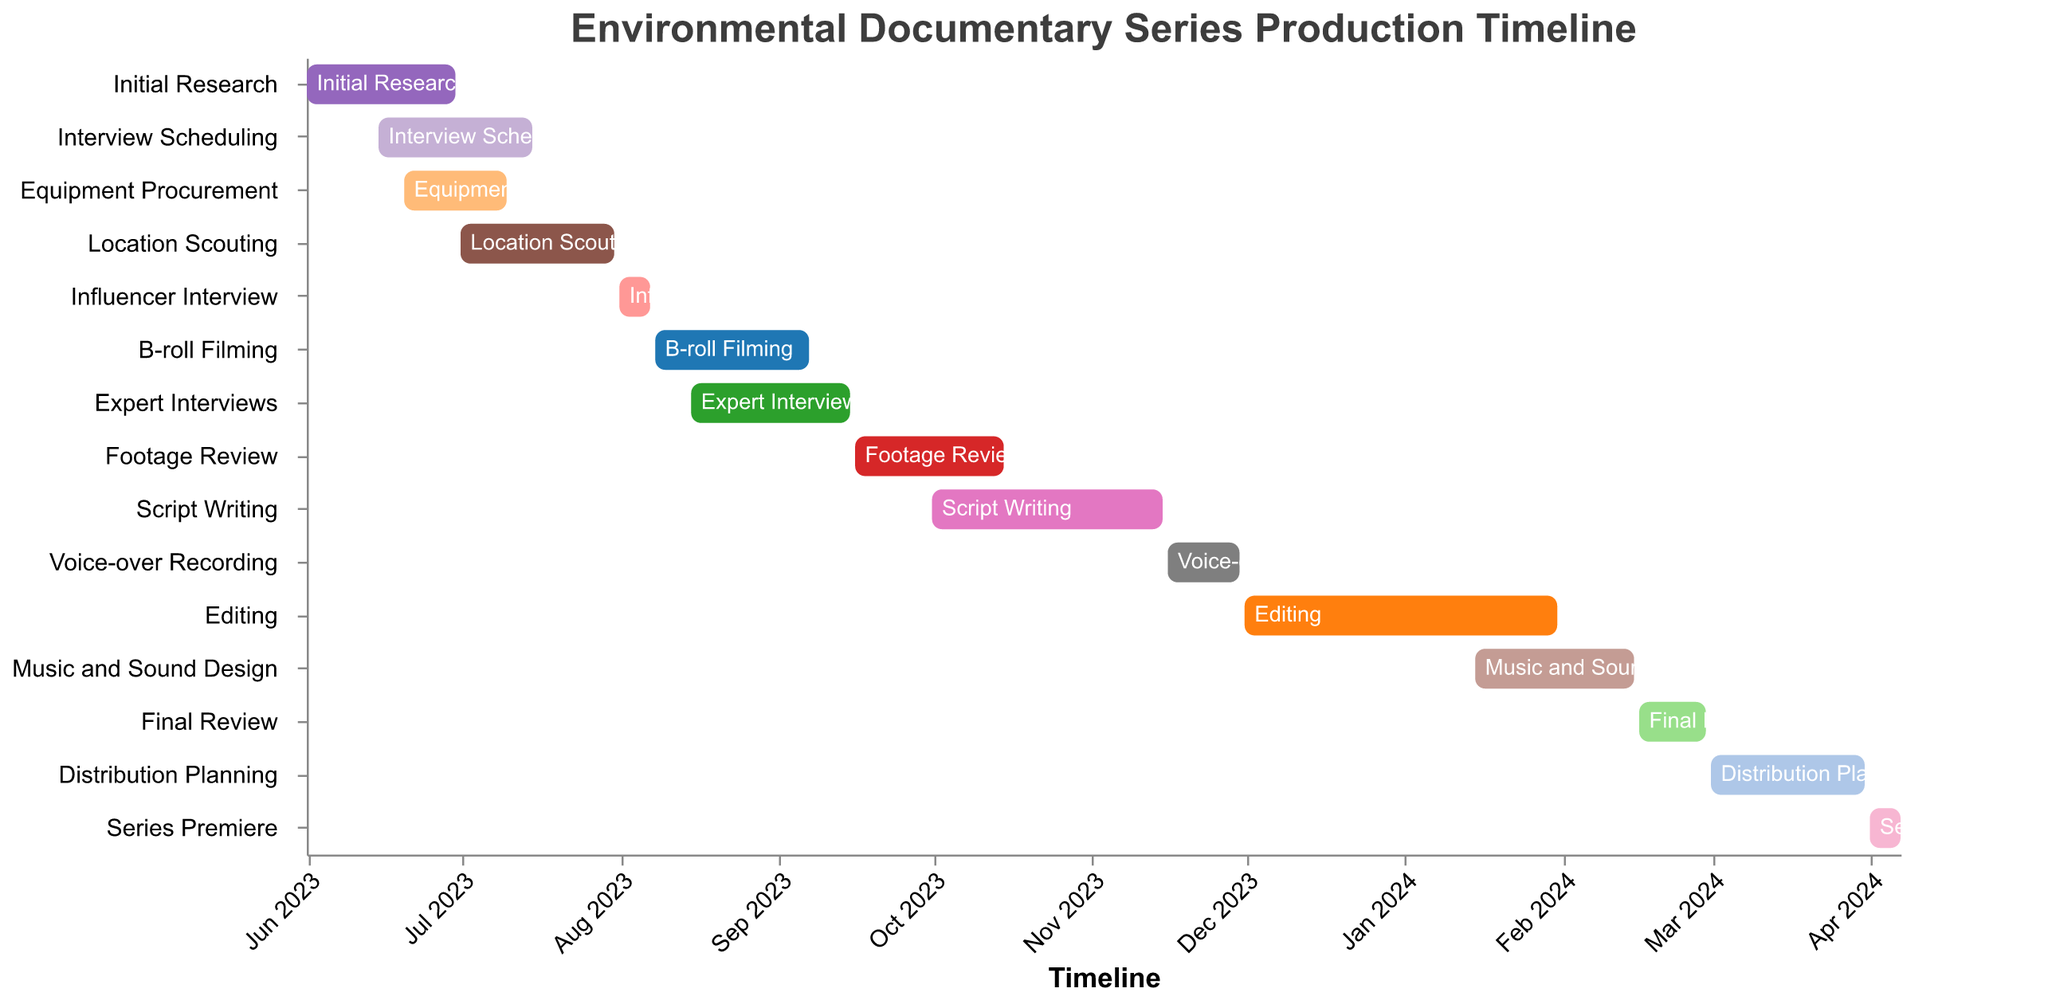What is the duration of the 'Initial Research' phase? The 'Initial Research' phase begins on 2023-06-01 and ends on 2023-06-30. The duration can be calculated by finding the difference between these two dates.
Answer: 30 days When does the 'Script Writing' phase start and end? According to the plotted data, the 'Script Writing' phase starts on 2023-10-01 and ends on 2023-11-15.
Answer: Starts: 2023-10-01, Ends: 2023-11-15 Which tasks overlap with the 'Interview Scheduling' phase? The 'Interview Scheduling' phase (2023-06-15 to 2023-07-15) overlaps with 'Initial Research' (ends 2023-06-30) and 'Equipment Procurement' (2023-06-20 to 2023-07-10).
Answer: 'Initial Research' and 'Equipment Procurement' What is the total time taken for the 'Editing' phase? The 'Editing' phase begins on 2023-12-01 and ends on 2024-01-31. The total time taken is the difference between these two dates.
Answer: 62 days Compare the duration of 'Footage Review' and 'Script Writing'. Which is longer? 'Footage Review' is from 2023-09-16 to 2023-10-15, and 'Script Writing' is from 2023-10-01 to 2023-11-15. Calculating the duration for each: 'Footage Review' is 30 days and 'Script Writing' is 45 days.
Answer: 'Script Writing' How much time is there between the end of 'Music and Sound Design' and the start of 'Final Review'? 'Music and Sound Design' ends on 2024-02-15 and 'Final Review' starts on 2024-02-16. There is no gap between these phases.
Answer: 0 days What is the task that immediately follows the 'Voice-over Recording' phase? The 'Voice-over Recording' phase ends on 2023-11-30, and the 'Editing' phase begins next on 2023-12-01.
Answer: 'Editing' Identify the longest single task in the timeline. By examining the durations, 'Editing' (2023-12-01 to 2024-01-31) is the longest task which spans 62 days.
Answer: 'Editing' How long after the 'Footage Review' phase does the 'Series Premiere' occur? 'Footage Review' ends on 2023-10-15. The 'Series Premiere' starts on 2024-04-01. Calculating the difference between these dates results in approximately 169 days.
Answer: 169 days What are the last two tasks before the 'Series Premiere'? The last two tasks before the 'Series Premiere' (2024-04-01 to 2024-04-07) are 'Distribution Planning' (2024-03-01 to 2024-03-31) and 'Final Review' (2024-02-16 to 2024-02-29).
Answer: 'Distribution Planning' and 'Final Review‘ 